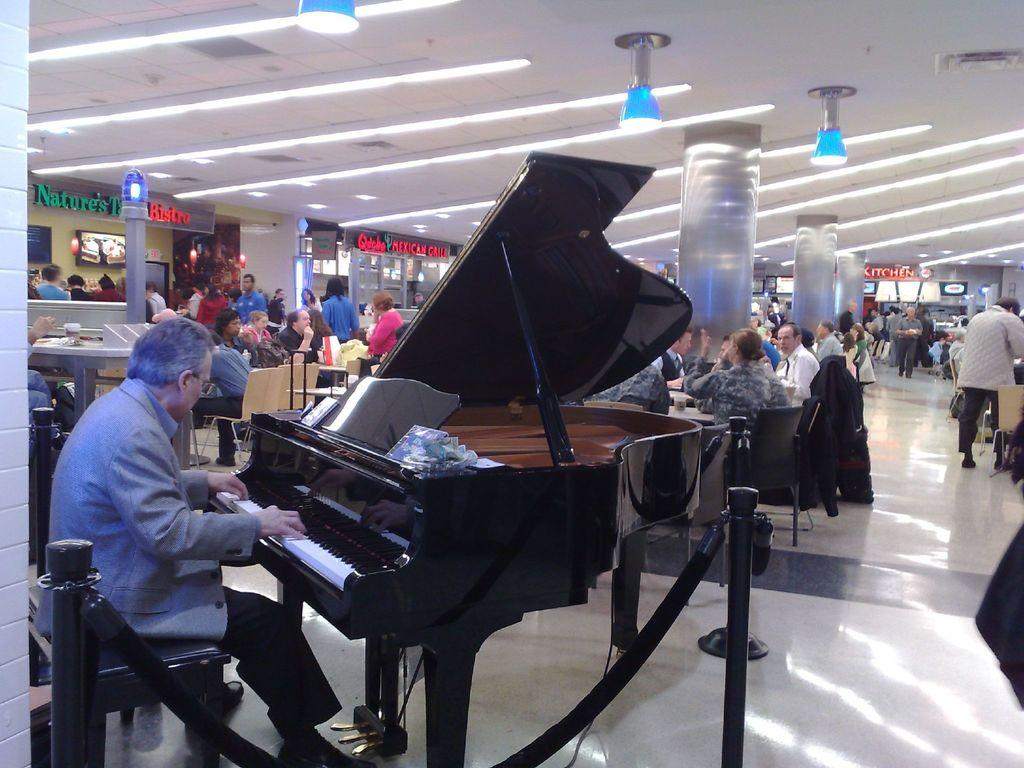What is the man in the image doing? The man is seated on a chair and playing a piano. How many people are present in the image? There are people seated and standing in the image. What are the people in the image doing? Some people are seated, while others are standing. How many beds can be seen in the image? There are no beds present in the image. What type of breath is the man taking while playing the piano? There is no information about the man's breath in the image. 